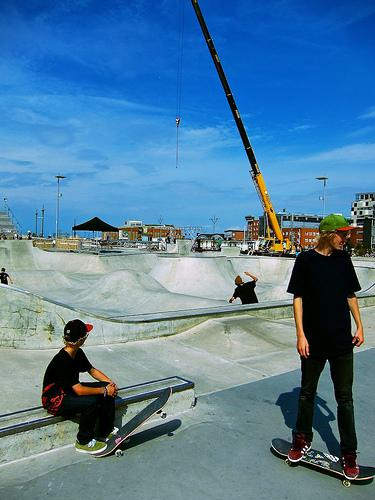Question: how many skateboarders are in this photograph?
Choices:
A. Four.
B. One.
C. Two.
D. Three.
Answer with the letter. Answer: A Question: when was this picture taken?
Choices:
A. Morning.
B. Midnight.
C. Daytime.
D. Afternoon.
Answer with the letter. Answer: C Question: where was this photo taken?
Choices:
A. Downtown.
B. In the alley.
C. At the pedestrians' crossing.
D. On the street.
Answer with the letter. Answer: D 